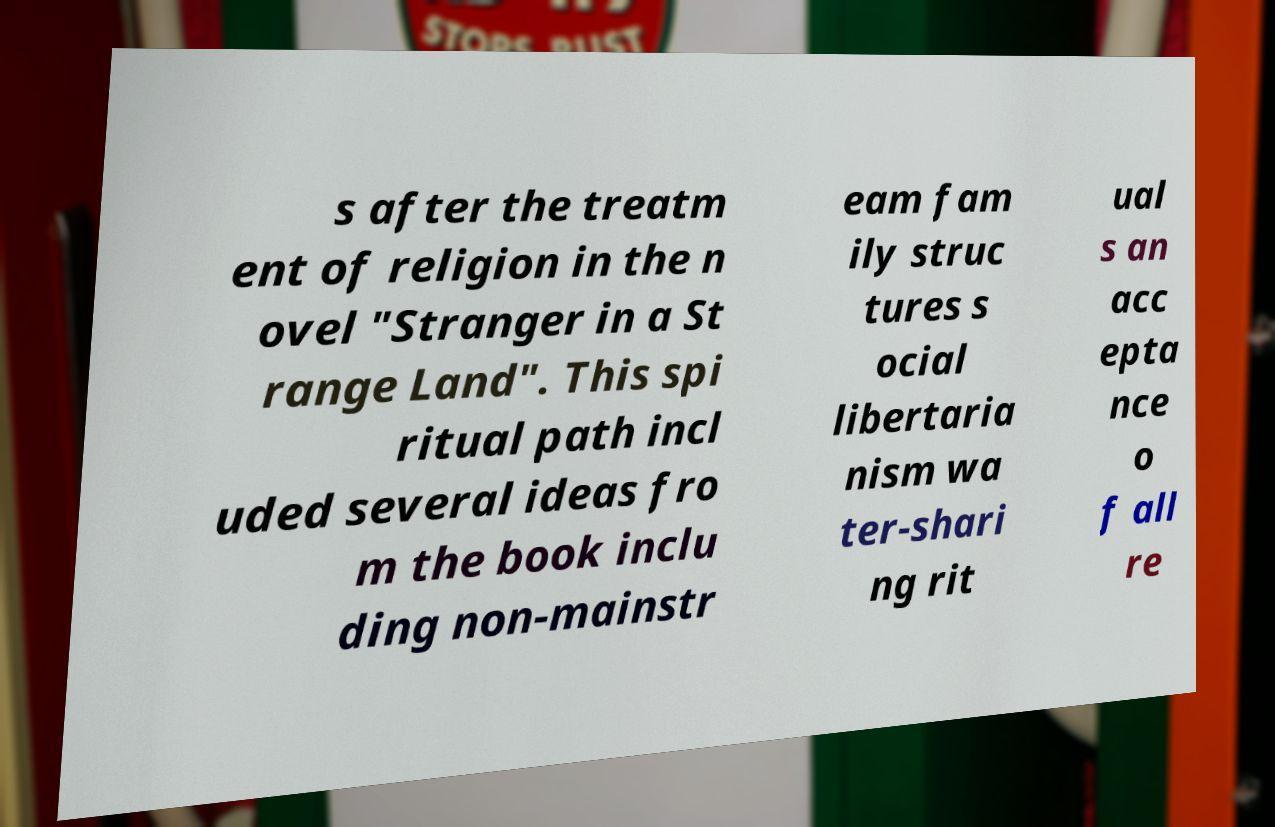Could you assist in decoding the text presented in this image and type it out clearly? s after the treatm ent of religion in the n ovel "Stranger in a St range Land". This spi ritual path incl uded several ideas fro m the book inclu ding non-mainstr eam fam ily struc tures s ocial libertaria nism wa ter-shari ng rit ual s an acc epta nce o f all re 